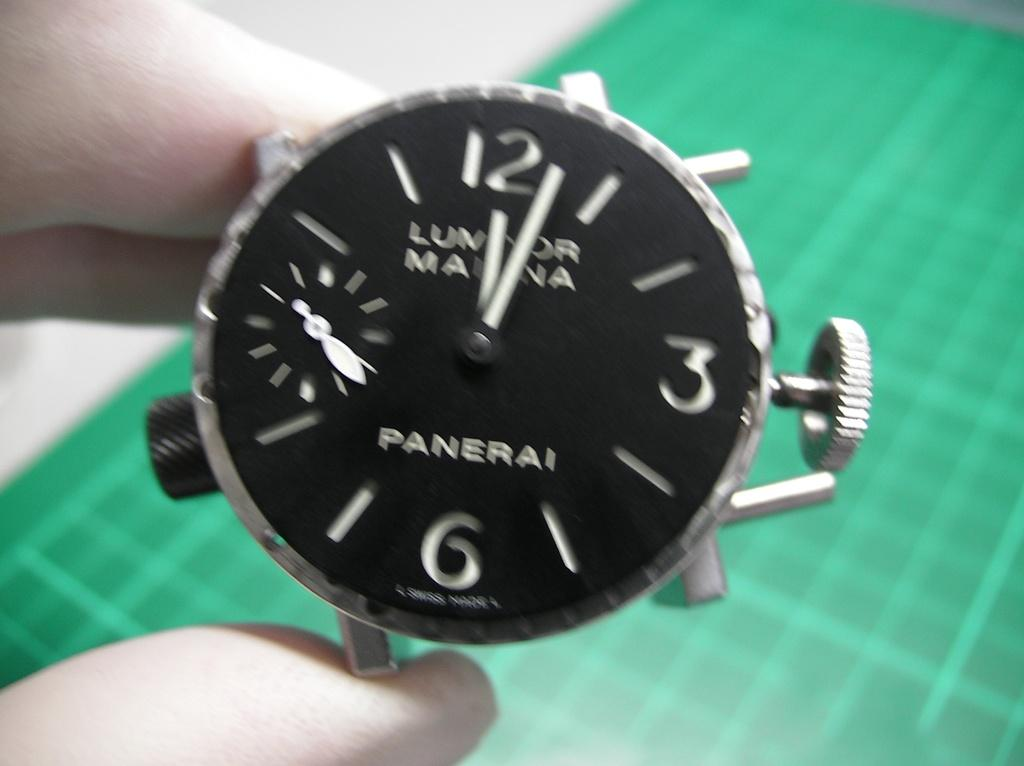Provide a one-sentence caption for the provided image. A blurred close up of a black faced Panerai watch which reads a few minutes after 12. 